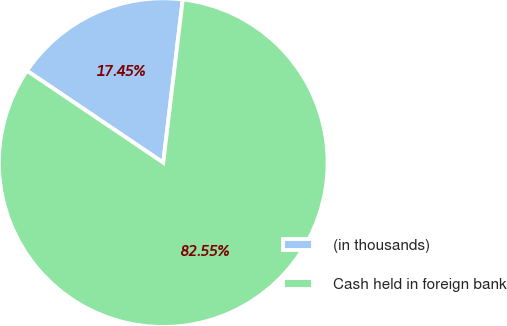<chart> <loc_0><loc_0><loc_500><loc_500><pie_chart><fcel>(in thousands)<fcel>Cash held in foreign bank<nl><fcel>17.45%<fcel>82.55%<nl></chart> 